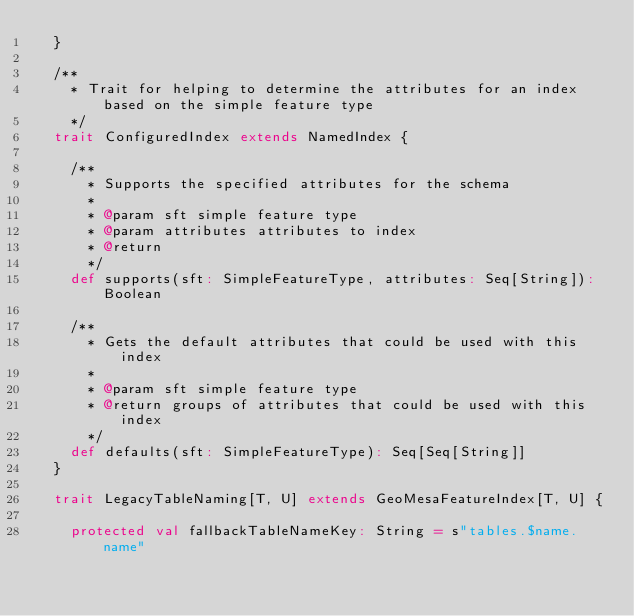<code> <loc_0><loc_0><loc_500><loc_500><_Scala_>  }

  /**
    * Trait for helping to determine the attributes for an index based on the simple feature type
    */
  trait ConfiguredIndex extends NamedIndex {

    /**
      * Supports the specified attributes for the schema
      *
      * @param sft simple feature type
      * @param attributes attributes to index
      * @return
      */
    def supports(sft: SimpleFeatureType, attributes: Seq[String]): Boolean

    /**
      * Gets the default attributes that could be used with this index
      *
      * @param sft simple feature type
      * @return groups of attributes that could be used with this index
      */
    def defaults(sft: SimpleFeatureType): Seq[Seq[String]]
  }

  trait LegacyTableNaming[T, U] extends GeoMesaFeatureIndex[T, U] {

    protected val fallbackTableNameKey: String = s"tables.$name.name"
</code> 